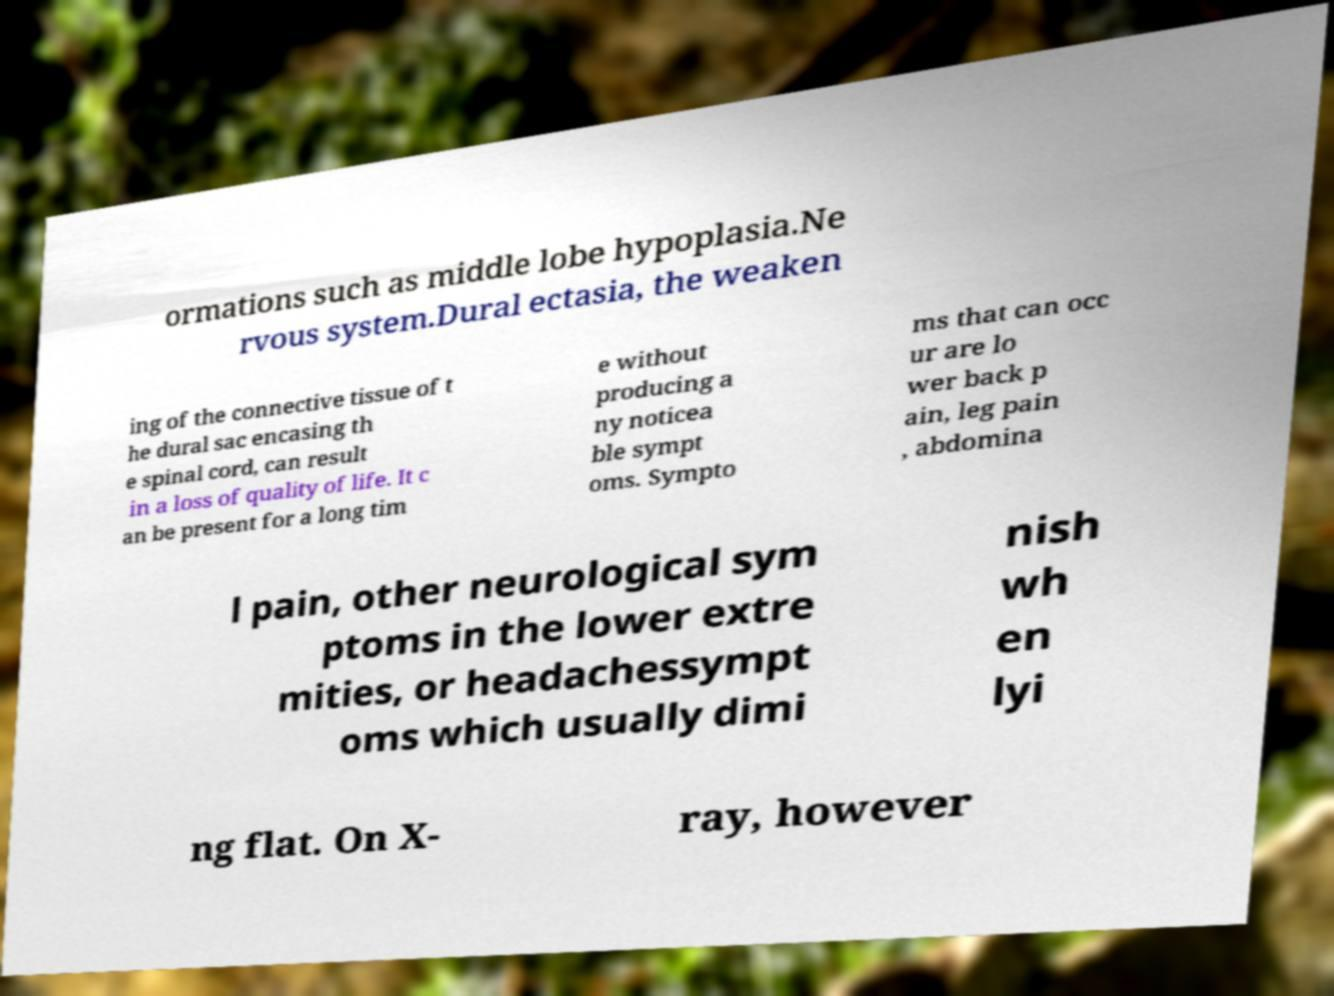Please identify and transcribe the text found in this image. ormations such as middle lobe hypoplasia.Ne rvous system.Dural ectasia, the weaken ing of the connective tissue of t he dural sac encasing th e spinal cord, can result in a loss of quality of life. It c an be present for a long tim e without producing a ny noticea ble sympt oms. Sympto ms that can occ ur are lo wer back p ain, leg pain , abdomina l pain, other neurological sym ptoms in the lower extre mities, or headachessympt oms which usually dimi nish wh en lyi ng flat. On X- ray, however 